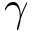Convert formula to latex. <formula><loc_0><loc_0><loc_500><loc_500>\gamma</formula> 